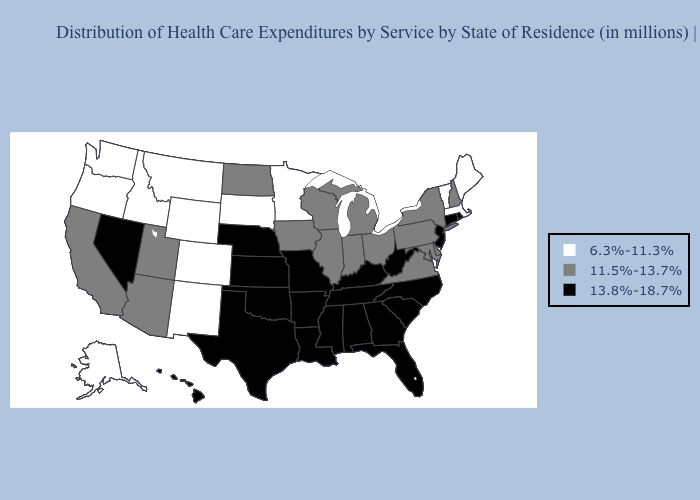Name the states that have a value in the range 11.5%-13.7%?
Short answer required. Arizona, California, Delaware, Illinois, Indiana, Iowa, Maryland, Michigan, New Hampshire, New York, North Dakota, Ohio, Pennsylvania, Utah, Virginia, Wisconsin. Does Texas have the highest value in the USA?
Write a very short answer. Yes. Does Tennessee have the same value as New York?
Keep it brief. No. Does Maryland have the lowest value in the South?
Quick response, please. Yes. Which states hav the highest value in the MidWest?
Be succinct. Kansas, Missouri, Nebraska. Does Idaho have the same value as Missouri?
Concise answer only. No. What is the value of Rhode Island?
Write a very short answer. 13.8%-18.7%. What is the value of Oregon?
Write a very short answer. 6.3%-11.3%. Name the states that have a value in the range 6.3%-11.3%?
Write a very short answer. Alaska, Colorado, Idaho, Maine, Massachusetts, Minnesota, Montana, New Mexico, Oregon, South Dakota, Vermont, Washington, Wyoming. What is the value of Idaho?
Concise answer only. 6.3%-11.3%. Does Nebraska have the highest value in the MidWest?
Be succinct. Yes. What is the value of South Dakota?
Quick response, please. 6.3%-11.3%. Name the states that have a value in the range 11.5%-13.7%?
Be succinct. Arizona, California, Delaware, Illinois, Indiana, Iowa, Maryland, Michigan, New Hampshire, New York, North Dakota, Ohio, Pennsylvania, Utah, Virginia, Wisconsin. Does Nebraska have the lowest value in the MidWest?
Write a very short answer. No. What is the value of California?
Keep it brief. 11.5%-13.7%. 